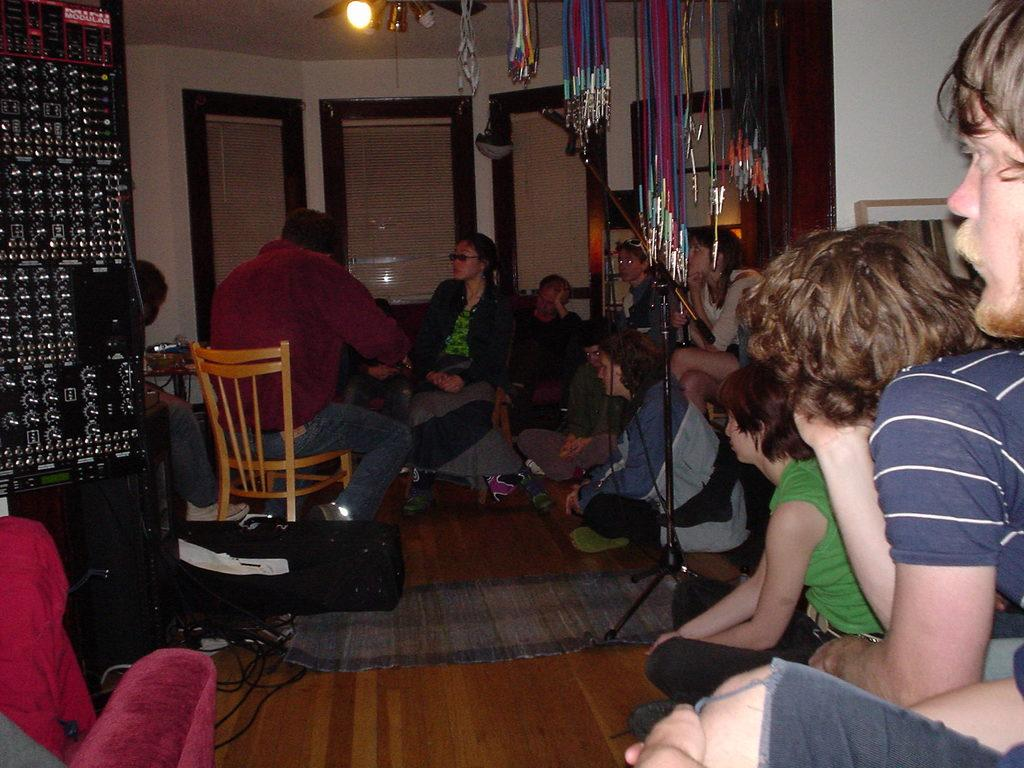What is happening on the right side of the image? There are people sitting on the right side of the image. What object can be seen in the right corner of the image? There is a microphone in the right corner of the image. What activity is taking place in the left corner of the image? There are two persons playing music in the left corner of the image. What type of insurance policy is being discussed by the people sitting on the right side of the image? There is no indication in the image that the people are discussing insurance policies. 